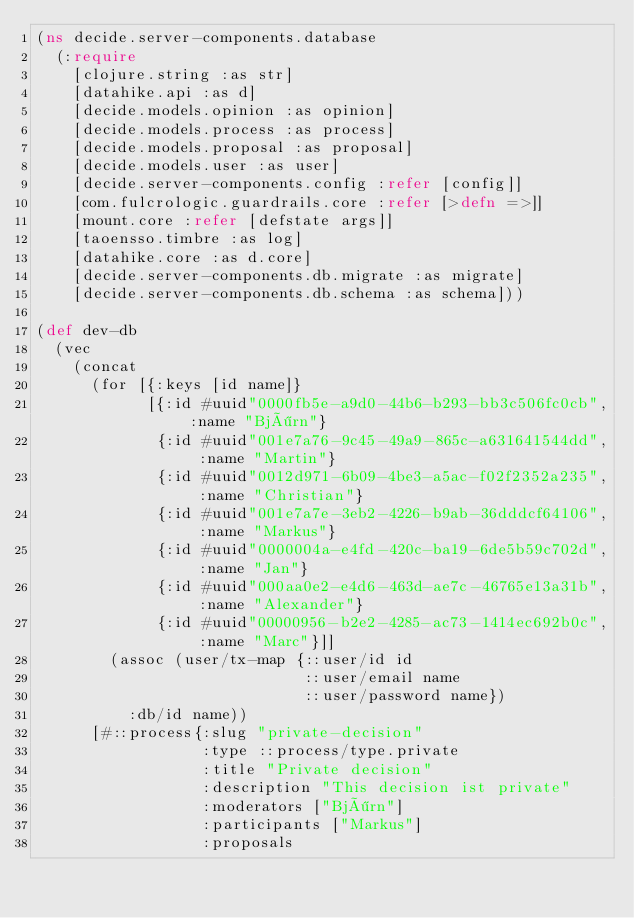Convert code to text. <code><loc_0><loc_0><loc_500><loc_500><_Clojure_>(ns decide.server-components.database
  (:require
    [clojure.string :as str]
    [datahike.api :as d]
    [decide.models.opinion :as opinion]
    [decide.models.process :as process]
    [decide.models.proposal :as proposal]
    [decide.models.user :as user]
    [decide.server-components.config :refer [config]]
    [com.fulcrologic.guardrails.core :refer [>defn =>]]
    [mount.core :refer [defstate args]]
    [taoensso.timbre :as log]
    [datahike.core :as d.core]
    [decide.server-components.db.migrate :as migrate]
    [decide.server-components.db.schema :as schema]))

(def dev-db
  (vec
    (concat
      (for [{:keys [id name]}
            [{:id #uuid"0000fb5e-a9d0-44b6-b293-bb3c506fc0cb", :name "Björn"}
             {:id #uuid"001e7a76-9c45-49a9-865c-a631641544dd", :name "Martin"}
             {:id #uuid"0012d971-6b09-4be3-a5ac-f02f2352a235", :name "Christian"}
             {:id #uuid"001e7a7e-3eb2-4226-b9ab-36dddcf64106", :name "Markus"}
             {:id #uuid"0000004a-e4fd-420c-ba19-6de5b59c702d", :name "Jan"}
             {:id #uuid"000aa0e2-e4d6-463d-ae7c-46765e13a31b", :name "Alexander"}
             {:id #uuid"00000956-b2e2-4285-ac73-1414ec692b0c", :name "Marc"}]]
        (assoc (user/tx-map {::user/id id
                             ::user/email name
                             ::user/password name})
          :db/id name))
      [#::process{:slug "private-decision"
                  :type ::process/type.private
                  :title "Private decision"
                  :description "This decision ist private"
                  :moderators ["Björn"]
                  :participants ["Markus"]
                  :proposals</code> 